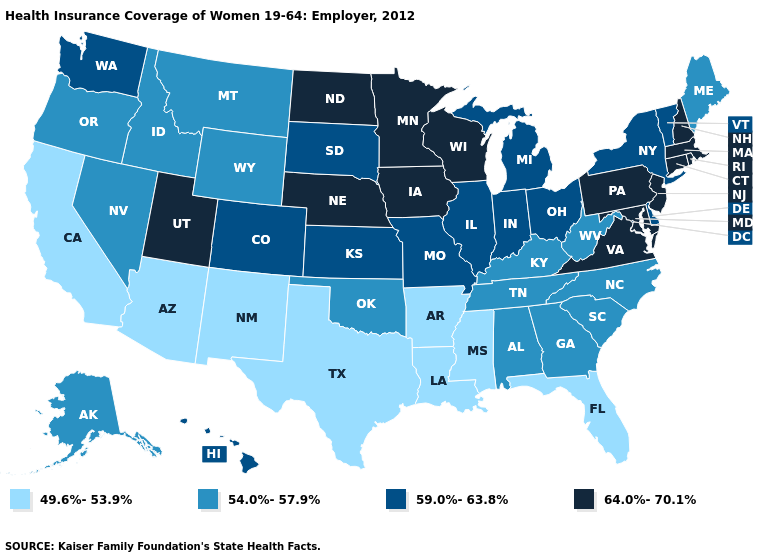What is the value of Idaho?
Be succinct. 54.0%-57.9%. What is the highest value in the Northeast ?
Concise answer only. 64.0%-70.1%. Name the states that have a value in the range 59.0%-63.8%?
Give a very brief answer. Colorado, Delaware, Hawaii, Illinois, Indiana, Kansas, Michigan, Missouri, New York, Ohio, South Dakota, Vermont, Washington. Name the states that have a value in the range 54.0%-57.9%?
Give a very brief answer. Alabama, Alaska, Georgia, Idaho, Kentucky, Maine, Montana, Nevada, North Carolina, Oklahoma, Oregon, South Carolina, Tennessee, West Virginia, Wyoming. What is the highest value in the USA?
Give a very brief answer. 64.0%-70.1%. What is the lowest value in the USA?
Answer briefly. 49.6%-53.9%. What is the value of Oregon?
Be succinct. 54.0%-57.9%. Is the legend a continuous bar?
Quick response, please. No. What is the highest value in states that border Tennessee?
Answer briefly. 64.0%-70.1%. What is the value of Kansas?
Answer briefly. 59.0%-63.8%. What is the lowest value in the USA?
Be succinct. 49.6%-53.9%. What is the value of West Virginia?
Quick response, please. 54.0%-57.9%. Does Alabama have the lowest value in the USA?
Keep it brief. No. Does the first symbol in the legend represent the smallest category?
Concise answer only. Yes. 